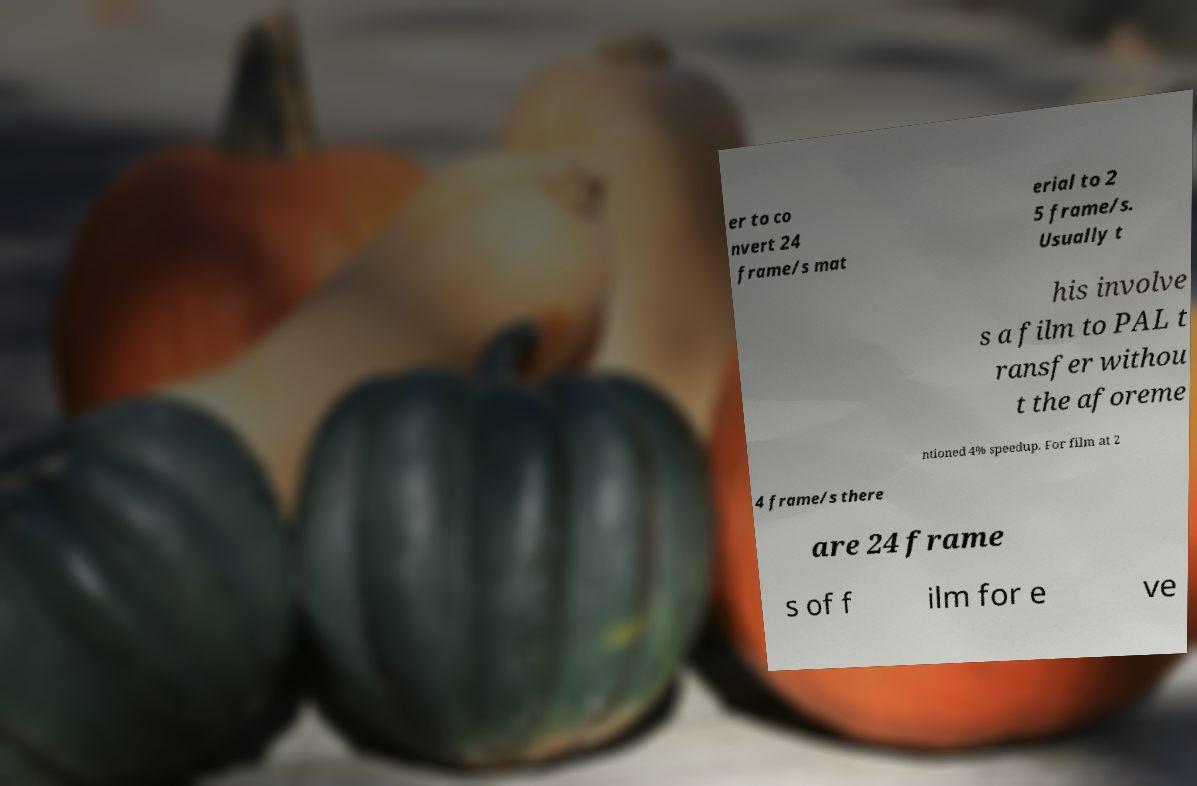Please identify and transcribe the text found in this image. er to co nvert 24 frame/s mat erial to 2 5 frame/s. Usually t his involve s a film to PAL t ransfer withou t the aforeme ntioned 4% speedup. For film at 2 4 frame/s there are 24 frame s of f ilm for e ve 